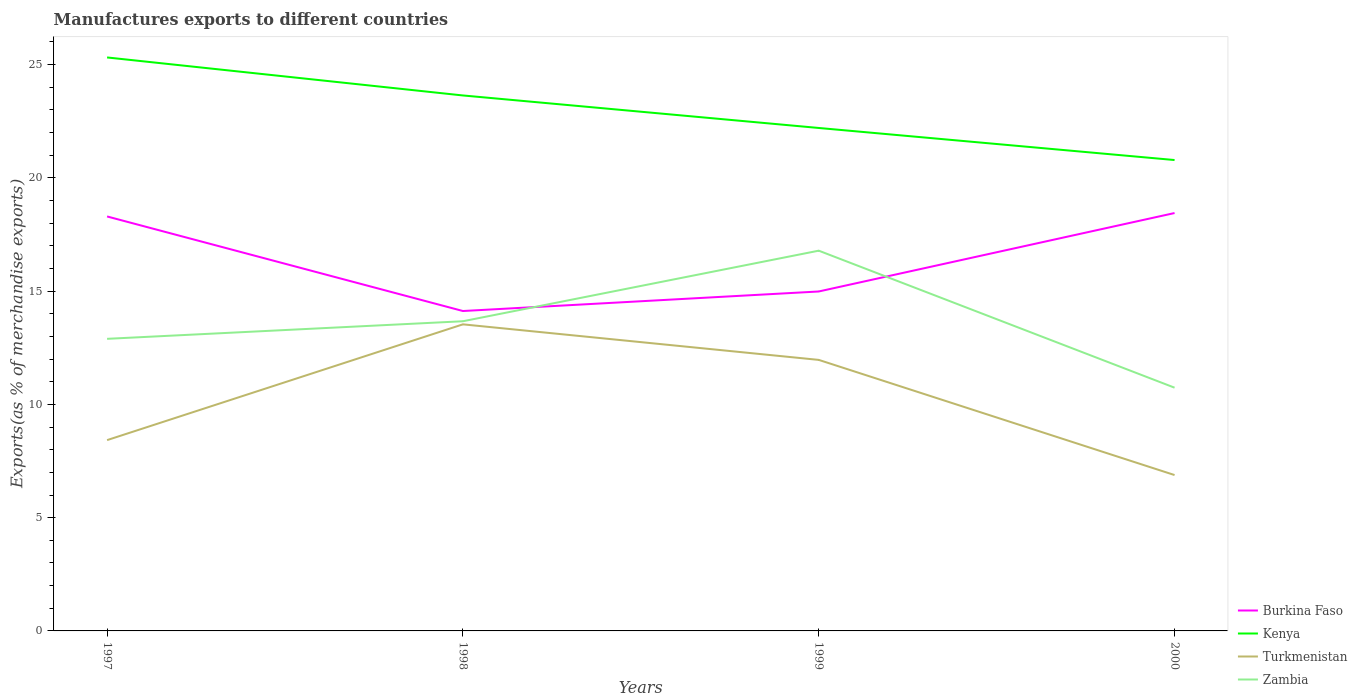How many different coloured lines are there?
Offer a terse response. 4. Does the line corresponding to Kenya intersect with the line corresponding to Zambia?
Your response must be concise. No. Is the number of lines equal to the number of legend labels?
Your answer should be very brief. Yes. Across all years, what is the maximum percentage of exports to different countries in Kenya?
Provide a succinct answer. 20.79. What is the total percentage of exports to different countries in Turkmenistan in the graph?
Give a very brief answer. 5.08. What is the difference between the highest and the second highest percentage of exports to different countries in Burkina Faso?
Provide a succinct answer. 4.32. What is the difference between two consecutive major ticks on the Y-axis?
Your answer should be compact. 5. Are the values on the major ticks of Y-axis written in scientific E-notation?
Your response must be concise. No. Does the graph contain any zero values?
Your answer should be compact. No. Does the graph contain grids?
Ensure brevity in your answer.  No. Where does the legend appear in the graph?
Your response must be concise. Bottom right. How many legend labels are there?
Offer a terse response. 4. How are the legend labels stacked?
Give a very brief answer. Vertical. What is the title of the graph?
Provide a short and direct response. Manufactures exports to different countries. What is the label or title of the Y-axis?
Your answer should be compact. Exports(as % of merchandise exports). What is the Exports(as % of merchandise exports) of Burkina Faso in 1997?
Offer a very short reply. 18.3. What is the Exports(as % of merchandise exports) of Kenya in 1997?
Provide a short and direct response. 25.32. What is the Exports(as % of merchandise exports) of Turkmenistan in 1997?
Your response must be concise. 8.42. What is the Exports(as % of merchandise exports) of Zambia in 1997?
Ensure brevity in your answer.  12.89. What is the Exports(as % of merchandise exports) in Burkina Faso in 1998?
Your response must be concise. 14.12. What is the Exports(as % of merchandise exports) in Kenya in 1998?
Your response must be concise. 23.64. What is the Exports(as % of merchandise exports) in Turkmenistan in 1998?
Your answer should be compact. 13.53. What is the Exports(as % of merchandise exports) in Zambia in 1998?
Your answer should be compact. 13.67. What is the Exports(as % of merchandise exports) in Burkina Faso in 1999?
Your answer should be compact. 14.98. What is the Exports(as % of merchandise exports) of Kenya in 1999?
Provide a short and direct response. 22.2. What is the Exports(as % of merchandise exports) of Turkmenistan in 1999?
Your response must be concise. 11.96. What is the Exports(as % of merchandise exports) of Zambia in 1999?
Offer a terse response. 16.79. What is the Exports(as % of merchandise exports) of Burkina Faso in 2000?
Your answer should be compact. 18.45. What is the Exports(as % of merchandise exports) of Kenya in 2000?
Keep it short and to the point. 20.79. What is the Exports(as % of merchandise exports) of Turkmenistan in 2000?
Your response must be concise. 6.88. What is the Exports(as % of merchandise exports) of Zambia in 2000?
Keep it short and to the point. 10.74. Across all years, what is the maximum Exports(as % of merchandise exports) in Burkina Faso?
Provide a succinct answer. 18.45. Across all years, what is the maximum Exports(as % of merchandise exports) in Kenya?
Your answer should be very brief. 25.32. Across all years, what is the maximum Exports(as % of merchandise exports) of Turkmenistan?
Ensure brevity in your answer.  13.53. Across all years, what is the maximum Exports(as % of merchandise exports) in Zambia?
Offer a very short reply. 16.79. Across all years, what is the minimum Exports(as % of merchandise exports) in Burkina Faso?
Your response must be concise. 14.12. Across all years, what is the minimum Exports(as % of merchandise exports) in Kenya?
Your answer should be very brief. 20.79. Across all years, what is the minimum Exports(as % of merchandise exports) in Turkmenistan?
Your answer should be very brief. 6.88. Across all years, what is the minimum Exports(as % of merchandise exports) in Zambia?
Ensure brevity in your answer.  10.74. What is the total Exports(as % of merchandise exports) in Burkina Faso in the graph?
Provide a succinct answer. 65.85. What is the total Exports(as % of merchandise exports) in Kenya in the graph?
Your answer should be compact. 91.95. What is the total Exports(as % of merchandise exports) in Turkmenistan in the graph?
Give a very brief answer. 40.8. What is the total Exports(as % of merchandise exports) of Zambia in the graph?
Your answer should be compact. 54.09. What is the difference between the Exports(as % of merchandise exports) of Burkina Faso in 1997 and that in 1998?
Provide a short and direct response. 4.17. What is the difference between the Exports(as % of merchandise exports) in Kenya in 1997 and that in 1998?
Make the answer very short. 1.68. What is the difference between the Exports(as % of merchandise exports) in Turkmenistan in 1997 and that in 1998?
Give a very brief answer. -5.11. What is the difference between the Exports(as % of merchandise exports) in Zambia in 1997 and that in 1998?
Provide a short and direct response. -0.78. What is the difference between the Exports(as % of merchandise exports) in Burkina Faso in 1997 and that in 1999?
Provide a succinct answer. 3.31. What is the difference between the Exports(as % of merchandise exports) of Kenya in 1997 and that in 1999?
Provide a succinct answer. 3.11. What is the difference between the Exports(as % of merchandise exports) of Turkmenistan in 1997 and that in 1999?
Your answer should be very brief. -3.54. What is the difference between the Exports(as % of merchandise exports) in Zambia in 1997 and that in 1999?
Ensure brevity in your answer.  -3.89. What is the difference between the Exports(as % of merchandise exports) of Burkina Faso in 1997 and that in 2000?
Your answer should be very brief. -0.15. What is the difference between the Exports(as % of merchandise exports) of Kenya in 1997 and that in 2000?
Ensure brevity in your answer.  4.53. What is the difference between the Exports(as % of merchandise exports) of Turkmenistan in 1997 and that in 2000?
Give a very brief answer. 1.54. What is the difference between the Exports(as % of merchandise exports) in Zambia in 1997 and that in 2000?
Give a very brief answer. 2.16. What is the difference between the Exports(as % of merchandise exports) in Burkina Faso in 1998 and that in 1999?
Your answer should be very brief. -0.86. What is the difference between the Exports(as % of merchandise exports) of Kenya in 1998 and that in 1999?
Provide a short and direct response. 1.44. What is the difference between the Exports(as % of merchandise exports) in Turkmenistan in 1998 and that in 1999?
Your answer should be compact. 1.57. What is the difference between the Exports(as % of merchandise exports) of Zambia in 1998 and that in 1999?
Offer a terse response. -3.12. What is the difference between the Exports(as % of merchandise exports) in Burkina Faso in 1998 and that in 2000?
Your response must be concise. -4.32. What is the difference between the Exports(as % of merchandise exports) in Kenya in 1998 and that in 2000?
Make the answer very short. 2.85. What is the difference between the Exports(as % of merchandise exports) of Turkmenistan in 1998 and that in 2000?
Ensure brevity in your answer.  6.65. What is the difference between the Exports(as % of merchandise exports) of Zambia in 1998 and that in 2000?
Keep it short and to the point. 2.93. What is the difference between the Exports(as % of merchandise exports) of Burkina Faso in 1999 and that in 2000?
Keep it short and to the point. -3.46. What is the difference between the Exports(as % of merchandise exports) in Kenya in 1999 and that in 2000?
Offer a terse response. 1.42. What is the difference between the Exports(as % of merchandise exports) in Turkmenistan in 1999 and that in 2000?
Provide a short and direct response. 5.08. What is the difference between the Exports(as % of merchandise exports) of Zambia in 1999 and that in 2000?
Keep it short and to the point. 6.05. What is the difference between the Exports(as % of merchandise exports) of Burkina Faso in 1997 and the Exports(as % of merchandise exports) of Kenya in 1998?
Make the answer very short. -5.34. What is the difference between the Exports(as % of merchandise exports) in Burkina Faso in 1997 and the Exports(as % of merchandise exports) in Turkmenistan in 1998?
Your response must be concise. 4.76. What is the difference between the Exports(as % of merchandise exports) in Burkina Faso in 1997 and the Exports(as % of merchandise exports) in Zambia in 1998?
Offer a very short reply. 4.63. What is the difference between the Exports(as % of merchandise exports) of Kenya in 1997 and the Exports(as % of merchandise exports) of Turkmenistan in 1998?
Your answer should be compact. 11.78. What is the difference between the Exports(as % of merchandise exports) of Kenya in 1997 and the Exports(as % of merchandise exports) of Zambia in 1998?
Offer a very short reply. 11.65. What is the difference between the Exports(as % of merchandise exports) of Turkmenistan in 1997 and the Exports(as % of merchandise exports) of Zambia in 1998?
Give a very brief answer. -5.25. What is the difference between the Exports(as % of merchandise exports) of Burkina Faso in 1997 and the Exports(as % of merchandise exports) of Kenya in 1999?
Provide a succinct answer. -3.91. What is the difference between the Exports(as % of merchandise exports) in Burkina Faso in 1997 and the Exports(as % of merchandise exports) in Turkmenistan in 1999?
Your answer should be very brief. 6.33. What is the difference between the Exports(as % of merchandise exports) in Burkina Faso in 1997 and the Exports(as % of merchandise exports) in Zambia in 1999?
Keep it short and to the point. 1.51. What is the difference between the Exports(as % of merchandise exports) in Kenya in 1997 and the Exports(as % of merchandise exports) in Turkmenistan in 1999?
Offer a terse response. 13.35. What is the difference between the Exports(as % of merchandise exports) of Kenya in 1997 and the Exports(as % of merchandise exports) of Zambia in 1999?
Offer a terse response. 8.53. What is the difference between the Exports(as % of merchandise exports) in Turkmenistan in 1997 and the Exports(as % of merchandise exports) in Zambia in 1999?
Provide a short and direct response. -8.36. What is the difference between the Exports(as % of merchandise exports) in Burkina Faso in 1997 and the Exports(as % of merchandise exports) in Kenya in 2000?
Ensure brevity in your answer.  -2.49. What is the difference between the Exports(as % of merchandise exports) in Burkina Faso in 1997 and the Exports(as % of merchandise exports) in Turkmenistan in 2000?
Offer a very short reply. 11.42. What is the difference between the Exports(as % of merchandise exports) in Burkina Faso in 1997 and the Exports(as % of merchandise exports) in Zambia in 2000?
Offer a very short reply. 7.56. What is the difference between the Exports(as % of merchandise exports) of Kenya in 1997 and the Exports(as % of merchandise exports) of Turkmenistan in 2000?
Offer a terse response. 18.44. What is the difference between the Exports(as % of merchandise exports) of Kenya in 1997 and the Exports(as % of merchandise exports) of Zambia in 2000?
Keep it short and to the point. 14.58. What is the difference between the Exports(as % of merchandise exports) of Turkmenistan in 1997 and the Exports(as % of merchandise exports) of Zambia in 2000?
Offer a terse response. -2.31. What is the difference between the Exports(as % of merchandise exports) in Burkina Faso in 1998 and the Exports(as % of merchandise exports) in Kenya in 1999?
Your response must be concise. -8.08. What is the difference between the Exports(as % of merchandise exports) in Burkina Faso in 1998 and the Exports(as % of merchandise exports) in Turkmenistan in 1999?
Ensure brevity in your answer.  2.16. What is the difference between the Exports(as % of merchandise exports) of Burkina Faso in 1998 and the Exports(as % of merchandise exports) of Zambia in 1999?
Offer a terse response. -2.66. What is the difference between the Exports(as % of merchandise exports) of Kenya in 1998 and the Exports(as % of merchandise exports) of Turkmenistan in 1999?
Your answer should be very brief. 11.67. What is the difference between the Exports(as % of merchandise exports) of Kenya in 1998 and the Exports(as % of merchandise exports) of Zambia in 1999?
Your response must be concise. 6.85. What is the difference between the Exports(as % of merchandise exports) of Turkmenistan in 1998 and the Exports(as % of merchandise exports) of Zambia in 1999?
Give a very brief answer. -3.25. What is the difference between the Exports(as % of merchandise exports) of Burkina Faso in 1998 and the Exports(as % of merchandise exports) of Kenya in 2000?
Give a very brief answer. -6.66. What is the difference between the Exports(as % of merchandise exports) in Burkina Faso in 1998 and the Exports(as % of merchandise exports) in Turkmenistan in 2000?
Provide a succinct answer. 7.24. What is the difference between the Exports(as % of merchandise exports) in Burkina Faso in 1998 and the Exports(as % of merchandise exports) in Zambia in 2000?
Your answer should be compact. 3.38. What is the difference between the Exports(as % of merchandise exports) of Kenya in 1998 and the Exports(as % of merchandise exports) of Turkmenistan in 2000?
Ensure brevity in your answer.  16.76. What is the difference between the Exports(as % of merchandise exports) in Kenya in 1998 and the Exports(as % of merchandise exports) in Zambia in 2000?
Ensure brevity in your answer.  12.9. What is the difference between the Exports(as % of merchandise exports) of Turkmenistan in 1998 and the Exports(as % of merchandise exports) of Zambia in 2000?
Provide a succinct answer. 2.8. What is the difference between the Exports(as % of merchandise exports) of Burkina Faso in 1999 and the Exports(as % of merchandise exports) of Kenya in 2000?
Provide a succinct answer. -5.8. What is the difference between the Exports(as % of merchandise exports) of Burkina Faso in 1999 and the Exports(as % of merchandise exports) of Turkmenistan in 2000?
Your answer should be very brief. 8.1. What is the difference between the Exports(as % of merchandise exports) of Burkina Faso in 1999 and the Exports(as % of merchandise exports) of Zambia in 2000?
Provide a succinct answer. 4.25. What is the difference between the Exports(as % of merchandise exports) of Kenya in 1999 and the Exports(as % of merchandise exports) of Turkmenistan in 2000?
Keep it short and to the point. 15.32. What is the difference between the Exports(as % of merchandise exports) in Kenya in 1999 and the Exports(as % of merchandise exports) in Zambia in 2000?
Your response must be concise. 11.47. What is the difference between the Exports(as % of merchandise exports) in Turkmenistan in 1999 and the Exports(as % of merchandise exports) in Zambia in 2000?
Offer a very short reply. 1.23. What is the average Exports(as % of merchandise exports) in Burkina Faso per year?
Give a very brief answer. 16.46. What is the average Exports(as % of merchandise exports) in Kenya per year?
Provide a succinct answer. 22.99. What is the average Exports(as % of merchandise exports) in Turkmenistan per year?
Offer a terse response. 10.2. What is the average Exports(as % of merchandise exports) of Zambia per year?
Your answer should be compact. 13.52. In the year 1997, what is the difference between the Exports(as % of merchandise exports) in Burkina Faso and Exports(as % of merchandise exports) in Kenya?
Your answer should be very brief. -7.02. In the year 1997, what is the difference between the Exports(as % of merchandise exports) in Burkina Faso and Exports(as % of merchandise exports) in Turkmenistan?
Your answer should be very brief. 9.87. In the year 1997, what is the difference between the Exports(as % of merchandise exports) in Burkina Faso and Exports(as % of merchandise exports) in Zambia?
Keep it short and to the point. 5.4. In the year 1997, what is the difference between the Exports(as % of merchandise exports) of Kenya and Exports(as % of merchandise exports) of Turkmenistan?
Your answer should be compact. 16.89. In the year 1997, what is the difference between the Exports(as % of merchandise exports) of Kenya and Exports(as % of merchandise exports) of Zambia?
Offer a terse response. 12.42. In the year 1997, what is the difference between the Exports(as % of merchandise exports) of Turkmenistan and Exports(as % of merchandise exports) of Zambia?
Keep it short and to the point. -4.47. In the year 1998, what is the difference between the Exports(as % of merchandise exports) in Burkina Faso and Exports(as % of merchandise exports) in Kenya?
Offer a very short reply. -9.52. In the year 1998, what is the difference between the Exports(as % of merchandise exports) of Burkina Faso and Exports(as % of merchandise exports) of Turkmenistan?
Provide a short and direct response. 0.59. In the year 1998, what is the difference between the Exports(as % of merchandise exports) in Burkina Faso and Exports(as % of merchandise exports) in Zambia?
Your answer should be very brief. 0.45. In the year 1998, what is the difference between the Exports(as % of merchandise exports) of Kenya and Exports(as % of merchandise exports) of Turkmenistan?
Give a very brief answer. 10.1. In the year 1998, what is the difference between the Exports(as % of merchandise exports) in Kenya and Exports(as % of merchandise exports) in Zambia?
Make the answer very short. 9.97. In the year 1998, what is the difference between the Exports(as % of merchandise exports) of Turkmenistan and Exports(as % of merchandise exports) of Zambia?
Your response must be concise. -0.14. In the year 1999, what is the difference between the Exports(as % of merchandise exports) of Burkina Faso and Exports(as % of merchandise exports) of Kenya?
Keep it short and to the point. -7.22. In the year 1999, what is the difference between the Exports(as % of merchandise exports) in Burkina Faso and Exports(as % of merchandise exports) in Turkmenistan?
Provide a short and direct response. 3.02. In the year 1999, what is the difference between the Exports(as % of merchandise exports) of Burkina Faso and Exports(as % of merchandise exports) of Zambia?
Your answer should be compact. -1.8. In the year 1999, what is the difference between the Exports(as % of merchandise exports) of Kenya and Exports(as % of merchandise exports) of Turkmenistan?
Keep it short and to the point. 10.24. In the year 1999, what is the difference between the Exports(as % of merchandise exports) of Kenya and Exports(as % of merchandise exports) of Zambia?
Provide a short and direct response. 5.42. In the year 1999, what is the difference between the Exports(as % of merchandise exports) in Turkmenistan and Exports(as % of merchandise exports) in Zambia?
Give a very brief answer. -4.82. In the year 2000, what is the difference between the Exports(as % of merchandise exports) of Burkina Faso and Exports(as % of merchandise exports) of Kenya?
Offer a very short reply. -2.34. In the year 2000, what is the difference between the Exports(as % of merchandise exports) of Burkina Faso and Exports(as % of merchandise exports) of Turkmenistan?
Your answer should be compact. 11.57. In the year 2000, what is the difference between the Exports(as % of merchandise exports) of Burkina Faso and Exports(as % of merchandise exports) of Zambia?
Ensure brevity in your answer.  7.71. In the year 2000, what is the difference between the Exports(as % of merchandise exports) in Kenya and Exports(as % of merchandise exports) in Turkmenistan?
Provide a succinct answer. 13.91. In the year 2000, what is the difference between the Exports(as % of merchandise exports) in Kenya and Exports(as % of merchandise exports) in Zambia?
Provide a short and direct response. 10.05. In the year 2000, what is the difference between the Exports(as % of merchandise exports) of Turkmenistan and Exports(as % of merchandise exports) of Zambia?
Provide a short and direct response. -3.86. What is the ratio of the Exports(as % of merchandise exports) of Burkina Faso in 1997 to that in 1998?
Make the answer very short. 1.3. What is the ratio of the Exports(as % of merchandise exports) in Kenya in 1997 to that in 1998?
Provide a succinct answer. 1.07. What is the ratio of the Exports(as % of merchandise exports) of Turkmenistan in 1997 to that in 1998?
Your answer should be compact. 0.62. What is the ratio of the Exports(as % of merchandise exports) in Zambia in 1997 to that in 1998?
Give a very brief answer. 0.94. What is the ratio of the Exports(as % of merchandise exports) in Burkina Faso in 1997 to that in 1999?
Your answer should be very brief. 1.22. What is the ratio of the Exports(as % of merchandise exports) in Kenya in 1997 to that in 1999?
Ensure brevity in your answer.  1.14. What is the ratio of the Exports(as % of merchandise exports) in Turkmenistan in 1997 to that in 1999?
Offer a very short reply. 0.7. What is the ratio of the Exports(as % of merchandise exports) in Zambia in 1997 to that in 1999?
Offer a terse response. 0.77. What is the ratio of the Exports(as % of merchandise exports) of Kenya in 1997 to that in 2000?
Your answer should be very brief. 1.22. What is the ratio of the Exports(as % of merchandise exports) of Turkmenistan in 1997 to that in 2000?
Keep it short and to the point. 1.22. What is the ratio of the Exports(as % of merchandise exports) of Zambia in 1997 to that in 2000?
Your answer should be very brief. 1.2. What is the ratio of the Exports(as % of merchandise exports) of Burkina Faso in 1998 to that in 1999?
Your answer should be very brief. 0.94. What is the ratio of the Exports(as % of merchandise exports) of Kenya in 1998 to that in 1999?
Offer a terse response. 1.06. What is the ratio of the Exports(as % of merchandise exports) in Turkmenistan in 1998 to that in 1999?
Your response must be concise. 1.13. What is the ratio of the Exports(as % of merchandise exports) in Zambia in 1998 to that in 1999?
Your response must be concise. 0.81. What is the ratio of the Exports(as % of merchandise exports) of Burkina Faso in 1998 to that in 2000?
Provide a short and direct response. 0.77. What is the ratio of the Exports(as % of merchandise exports) of Kenya in 1998 to that in 2000?
Your answer should be very brief. 1.14. What is the ratio of the Exports(as % of merchandise exports) in Turkmenistan in 1998 to that in 2000?
Offer a terse response. 1.97. What is the ratio of the Exports(as % of merchandise exports) in Zambia in 1998 to that in 2000?
Your response must be concise. 1.27. What is the ratio of the Exports(as % of merchandise exports) of Burkina Faso in 1999 to that in 2000?
Make the answer very short. 0.81. What is the ratio of the Exports(as % of merchandise exports) in Kenya in 1999 to that in 2000?
Keep it short and to the point. 1.07. What is the ratio of the Exports(as % of merchandise exports) in Turkmenistan in 1999 to that in 2000?
Your answer should be compact. 1.74. What is the ratio of the Exports(as % of merchandise exports) of Zambia in 1999 to that in 2000?
Your answer should be compact. 1.56. What is the difference between the highest and the second highest Exports(as % of merchandise exports) in Burkina Faso?
Give a very brief answer. 0.15. What is the difference between the highest and the second highest Exports(as % of merchandise exports) in Kenya?
Make the answer very short. 1.68. What is the difference between the highest and the second highest Exports(as % of merchandise exports) in Turkmenistan?
Provide a short and direct response. 1.57. What is the difference between the highest and the second highest Exports(as % of merchandise exports) in Zambia?
Provide a succinct answer. 3.12. What is the difference between the highest and the lowest Exports(as % of merchandise exports) of Burkina Faso?
Make the answer very short. 4.32. What is the difference between the highest and the lowest Exports(as % of merchandise exports) of Kenya?
Offer a terse response. 4.53. What is the difference between the highest and the lowest Exports(as % of merchandise exports) in Turkmenistan?
Your response must be concise. 6.65. What is the difference between the highest and the lowest Exports(as % of merchandise exports) in Zambia?
Make the answer very short. 6.05. 